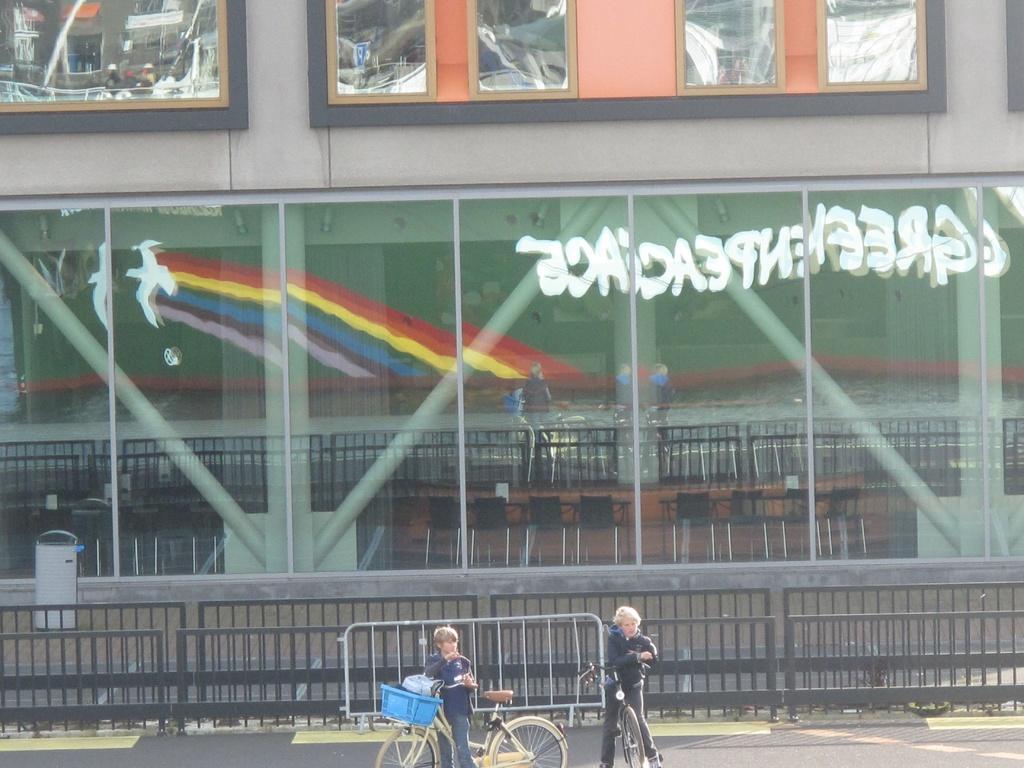What does the backwards word say?
Provide a succinct answer. Greenpeace. 